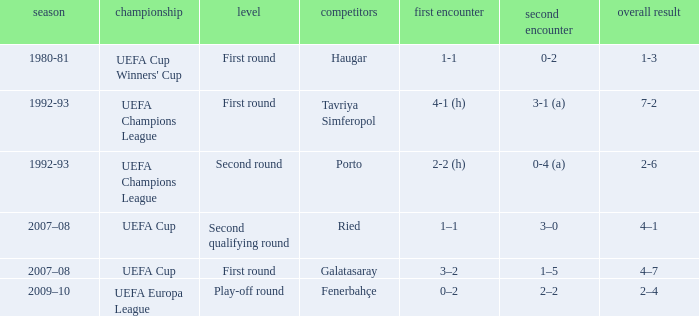What is the total number of round where opponents is haugar 1.0. 